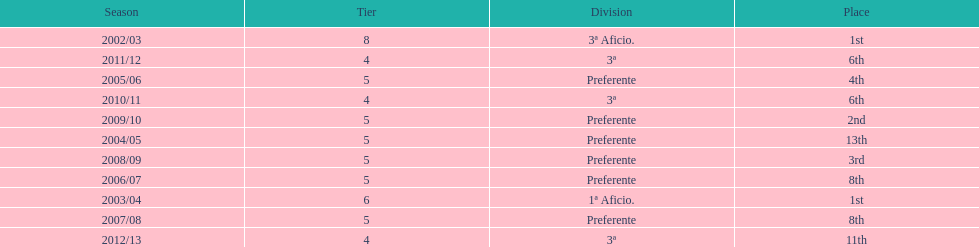What place was 1a aficio and 3a aficio? 1st. 